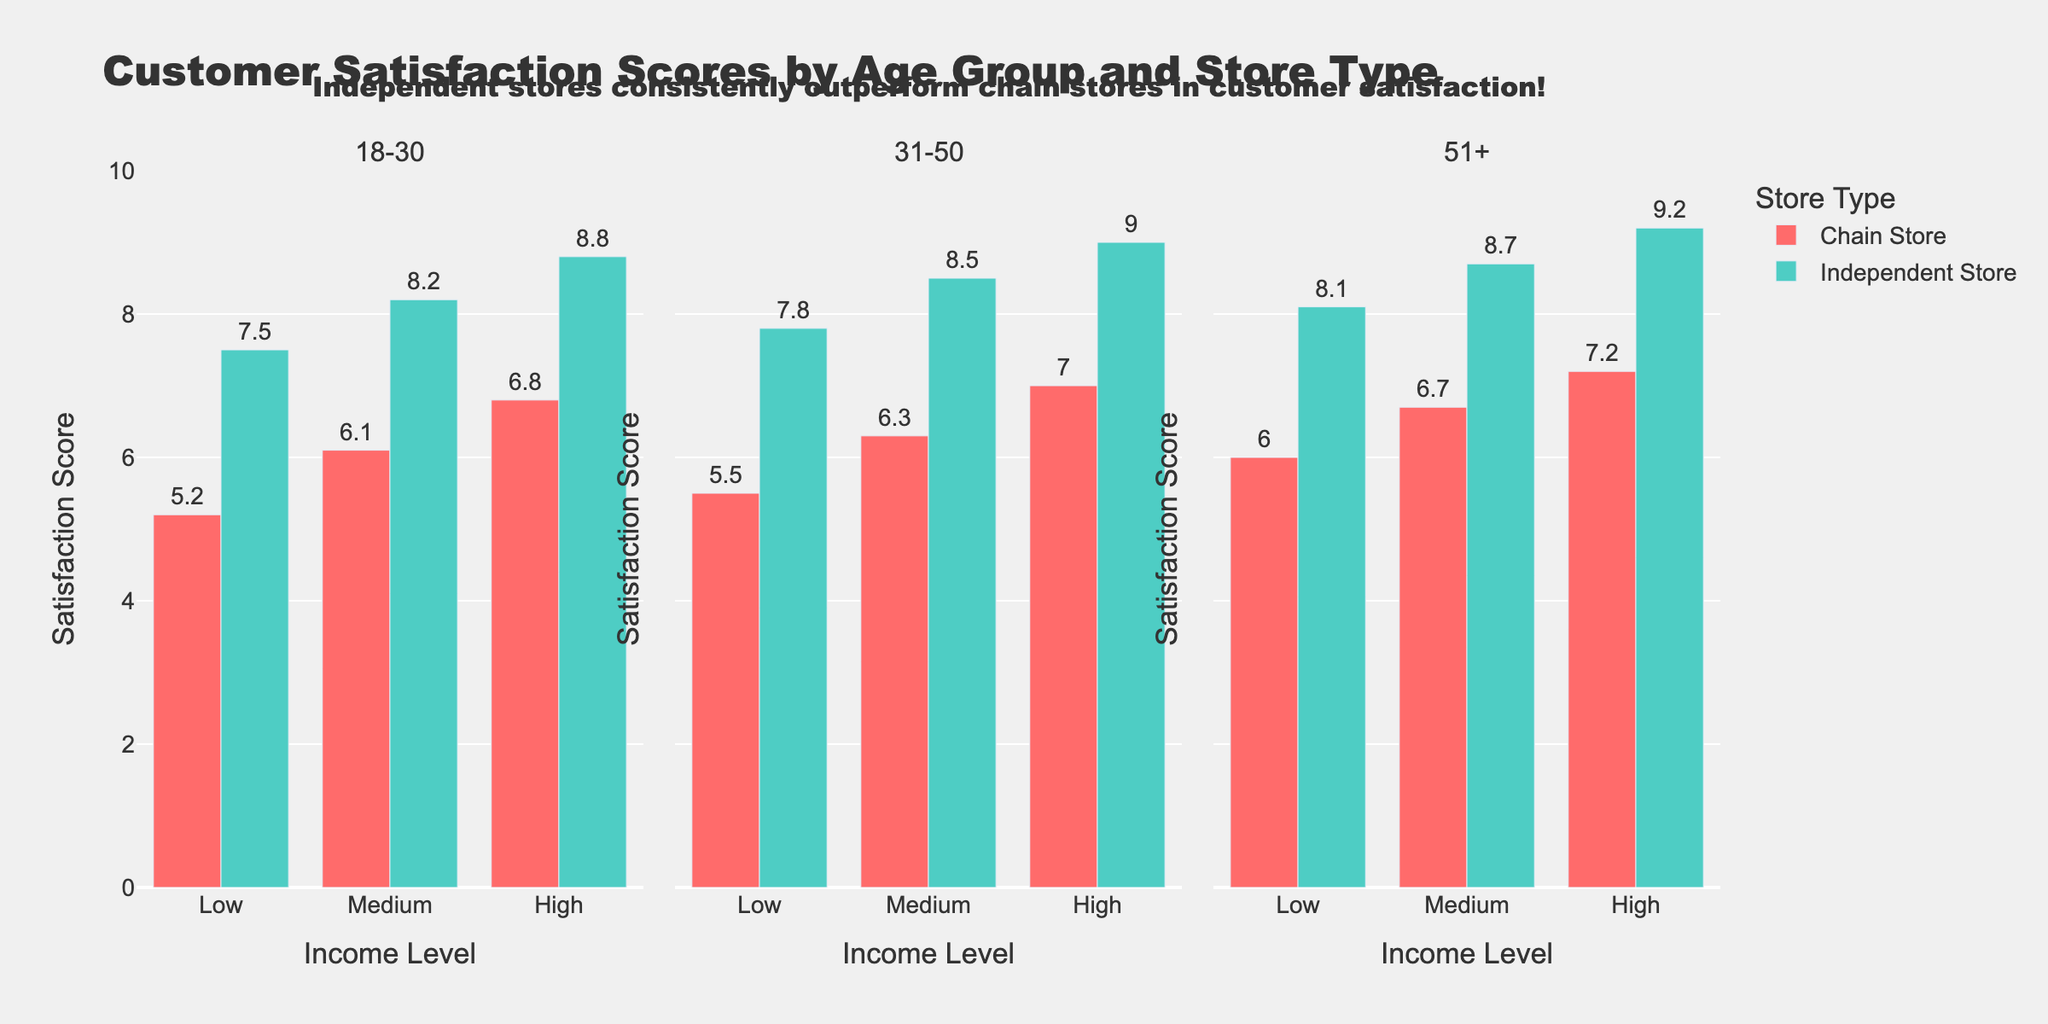What is the title of the figure? The title typically appears at the top of the figure and gives a high-level summary of the content. In this case, the title is "Evolution of Drone Technology in Military Operations", which reflects the overall theme of the figure.
Answer: Evolution of Drone Technology in Military Operations Which Drone Type had the highest Deployment Frequency in 2019? By looking at the first subplot (line plot), you can see that the RQ-11 Raven had the highest point in 2019 compared to other drone types.
Answer: RQ-11 Raven What is the average operational altitude of drones in 2019? To find this, look at the bar chart (second subplot). The altitudes listed for each drone type in 2019 are: RQ-11 Raven (300 ft), MQ-9 Reaper (34000 ft), RQ-7 Shadow (11500 ft), RQ-4 Global Hawk (62500 ft), MQ-25 Stingray (42500 ft). Calculate the average: (300 + 34000 + 11500 + 62500 + 42500) / 5.
Answer: 30160 ft Which Mission Type has the highest deployment frequency? To answer this, look at the pie chart (third subplot) which shows the distribution of mission type. Reconnaissance has the largest portion in the pie chart.
Answer: Reconnaissance How did the Deployment Frequency of the MQ-1 Predator change from 2010 to 2019? Refer to the line plot in the first subplot. The MQ-1 Predator appears in 2010 with 200 deployments and shows a decline in 2013 to 250 deployments. It does not have any data points after 2013, indicating it might have phased out or reduced.
Answer: Decreased What is the sum of the Deployment Frequencies of all drones in 2016? Look at the line plot in the first subplot to find the deployment values for each drone in 2016: RQ-11 Raven (750), MQ-9 Reaper (300), RQ-7 Shadow (500), RQ-4 Global Hawk (50). Sum these values: 750 + 300 + 500 + 50 = 1600.
Answer: 1600 Which drone type was introduced between 2013 and 2016? By comparing the heatmap, we can see a new column appear for the MQ-9 Reaper between 2013 and 2016.
Answer: MQ-9 Reaper What is the operational altitude range of the RQ-4 Global Hawk? Refer to the bar chart (second subplot) that shows the operational altitude by drone type. The bar for RQ-4 Global Hawk is approximately at 62500 ft.
Answer: 60000-65000 ft 